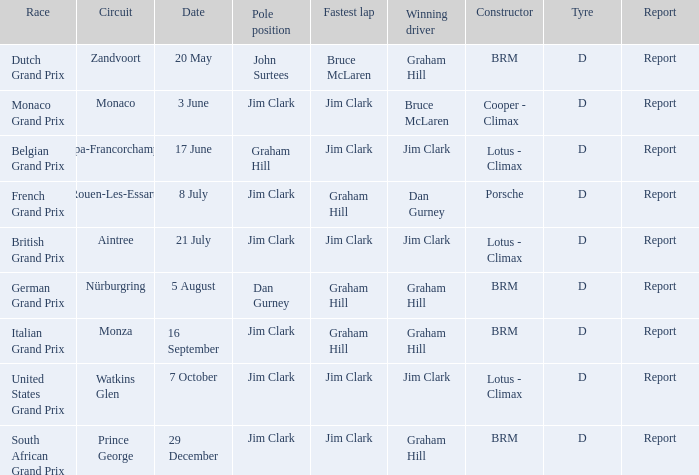What is the tyre for the circuit of Prince George, which had Jim Clark as the fastest lap? D. Would you mind parsing the complete table? {'header': ['Race', 'Circuit', 'Date', 'Pole position', 'Fastest lap', 'Winning driver', 'Constructor', 'Tyre', 'Report'], 'rows': [['Dutch Grand Prix', 'Zandvoort', '20 May', 'John Surtees', 'Bruce McLaren', 'Graham Hill', 'BRM', 'D', 'Report'], ['Monaco Grand Prix', 'Monaco', '3 June', 'Jim Clark', 'Jim Clark', 'Bruce McLaren', 'Cooper - Climax', 'D', 'Report'], ['Belgian Grand Prix', 'Spa-Francorchamps', '17 June', 'Graham Hill', 'Jim Clark', 'Jim Clark', 'Lotus - Climax', 'D', 'Report'], ['French Grand Prix', 'Rouen-Les-Essarts', '8 July', 'Jim Clark', 'Graham Hill', 'Dan Gurney', 'Porsche', 'D', 'Report'], ['British Grand Prix', 'Aintree', '21 July', 'Jim Clark', 'Jim Clark', 'Jim Clark', 'Lotus - Climax', 'D', 'Report'], ['German Grand Prix', 'Nürburgring', '5 August', 'Dan Gurney', 'Graham Hill', 'Graham Hill', 'BRM', 'D', 'Report'], ['Italian Grand Prix', 'Monza', '16 September', 'Jim Clark', 'Graham Hill', 'Graham Hill', 'BRM', 'D', 'Report'], ['United States Grand Prix', 'Watkins Glen', '7 October', 'Jim Clark', 'Jim Clark', 'Jim Clark', 'Lotus - Climax', 'D', 'Report'], ['South African Grand Prix', 'Prince George', '29 December', 'Jim Clark', 'Jim Clark', 'Graham Hill', 'BRM', 'D', 'Report']]} 